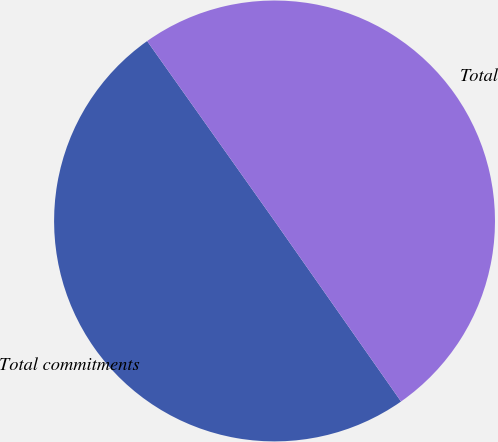Convert chart to OTSL. <chart><loc_0><loc_0><loc_500><loc_500><pie_chart><fcel>Total commitments<fcel>Total<nl><fcel>49.92%<fcel>50.08%<nl></chart> 